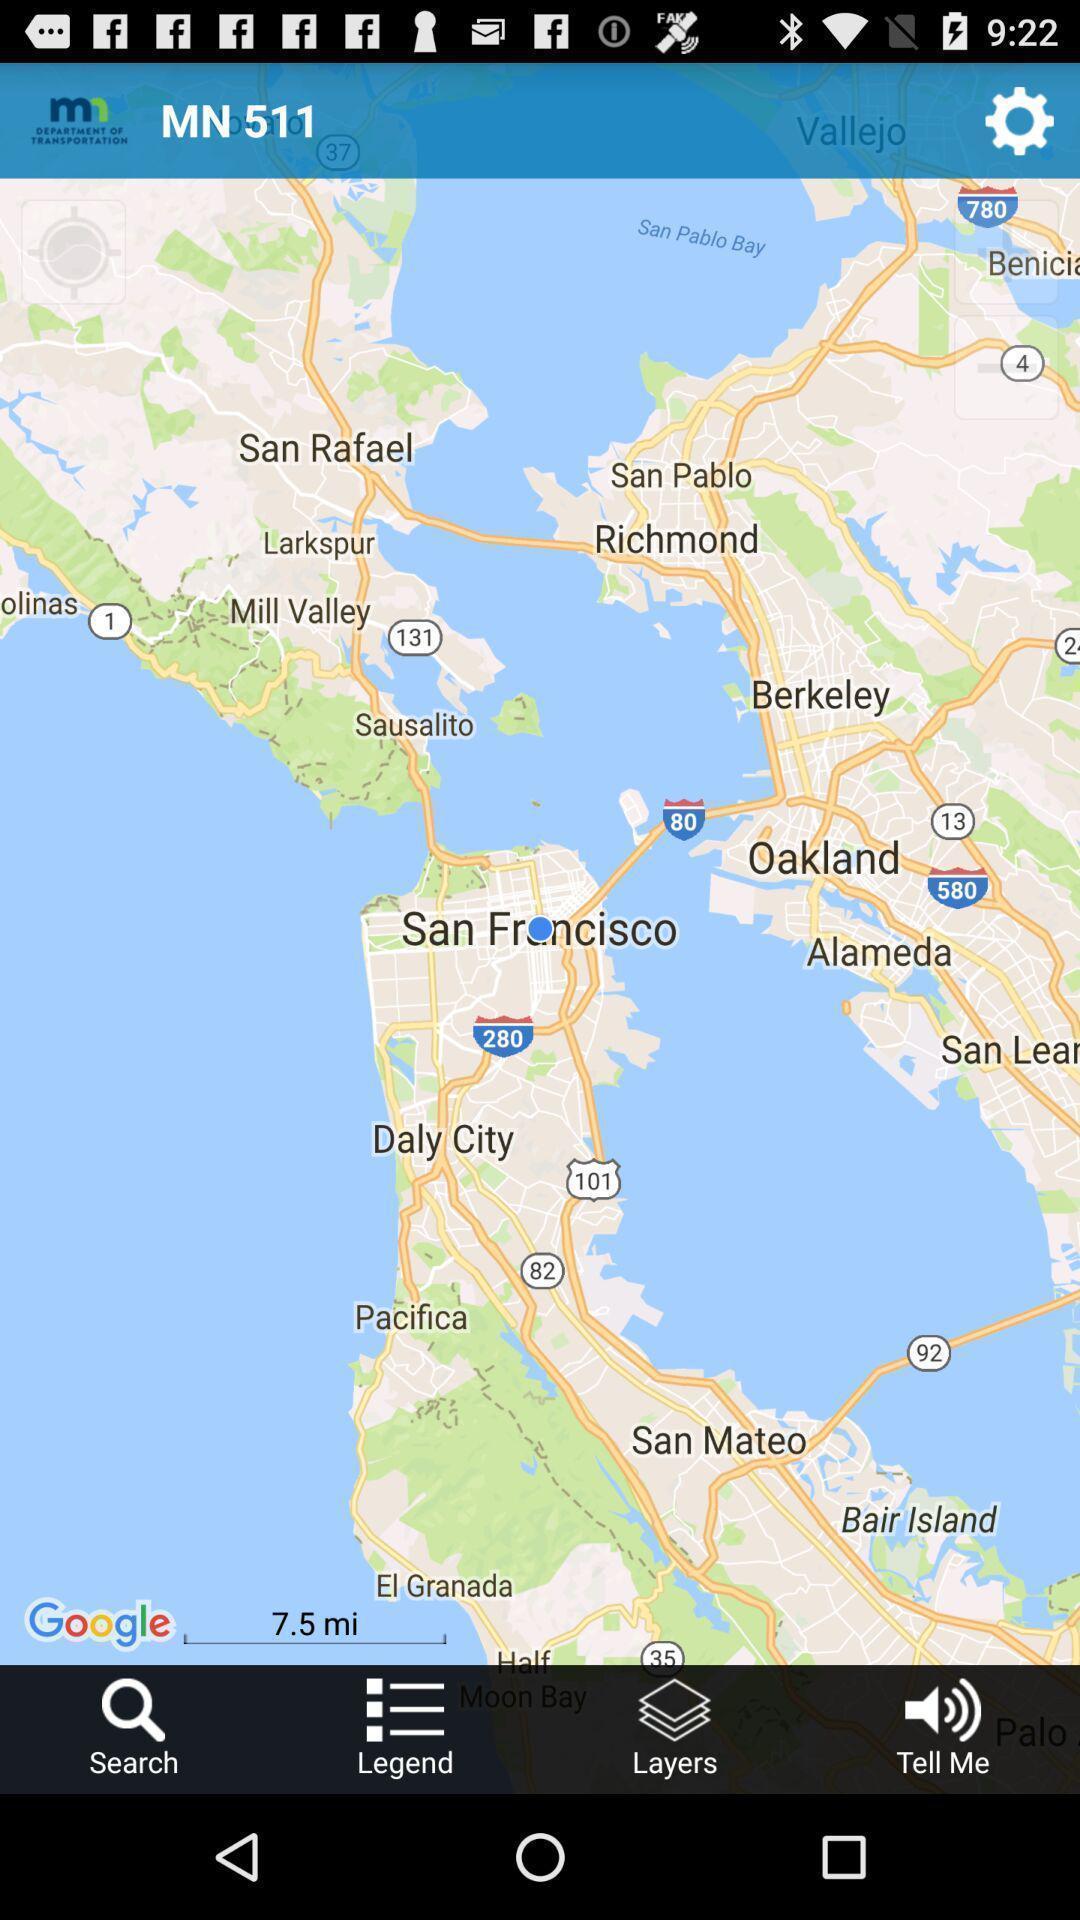What details can you identify in this image? Showing various locations in map app. 